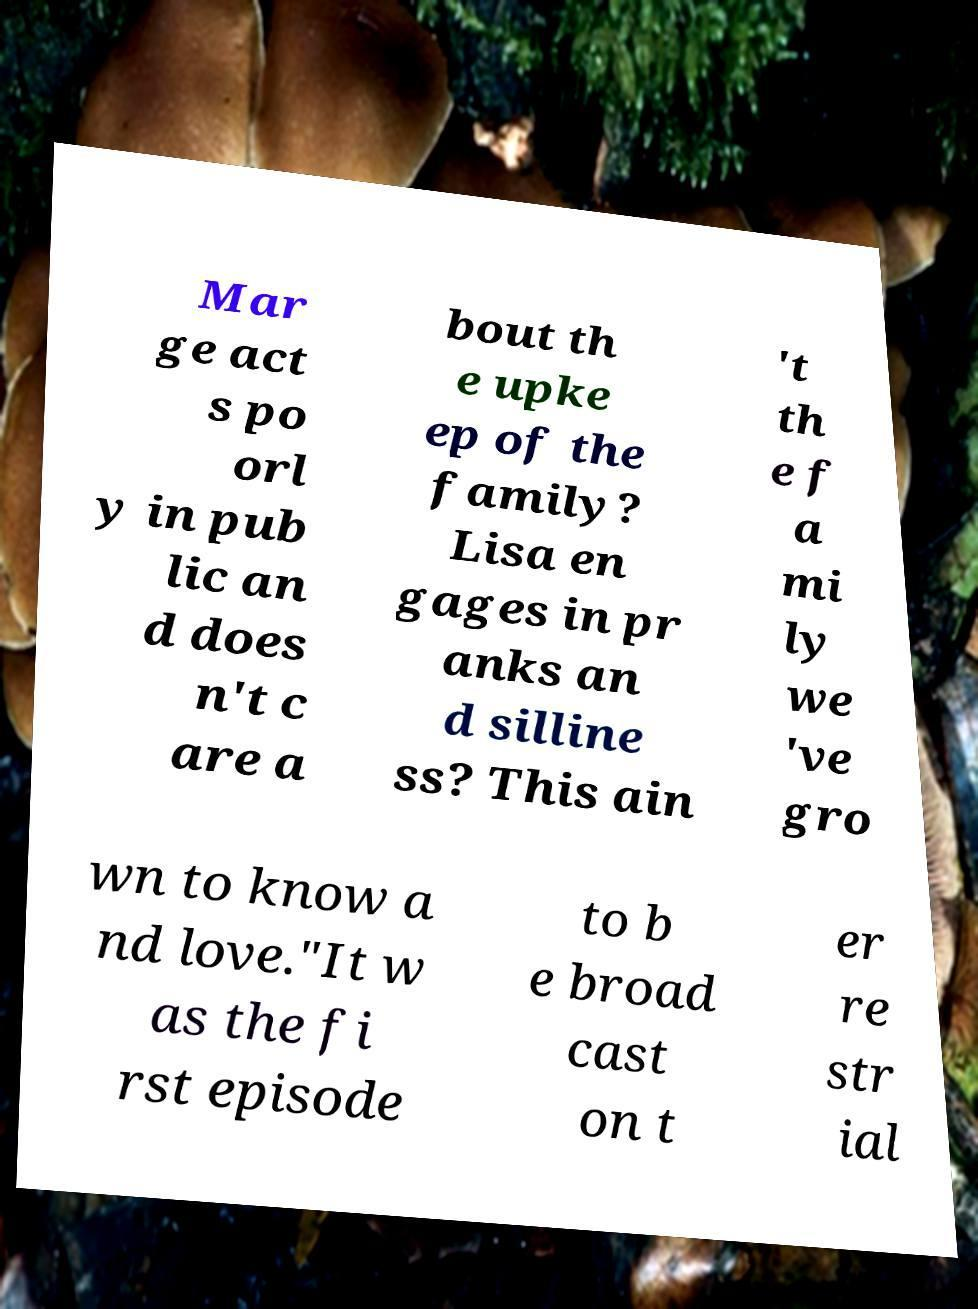Could you extract and type out the text from this image? Mar ge act s po orl y in pub lic an d does n't c are a bout th e upke ep of the family? Lisa en gages in pr anks an d silline ss? This ain 't th e f a mi ly we 've gro wn to know a nd love."It w as the fi rst episode to b e broad cast on t er re str ial 